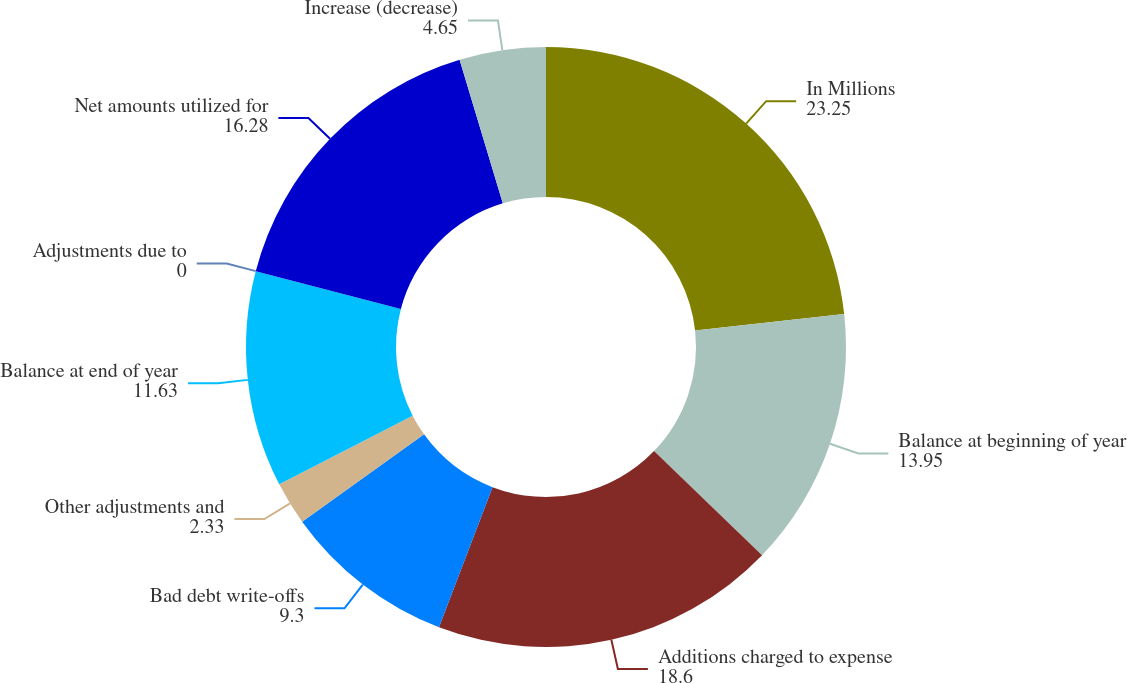<chart> <loc_0><loc_0><loc_500><loc_500><pie_chart><fcel>In Millions<fcel>Balance at beginning of year<fcel>Additions charged to expense<fcel>Bad debt write-offs<fcel>Other adjustments and<fcel>Balance at end of year<fcel>Adjustments due to<fcel>Net amounts utilized for<fcel>Increase (decrease)<nl><fcel>23.25%<fcel>13.95%<fcel>18.6%<fcel>9.3%<fcel>2.33%<fcel>11.63%<fcel>0.0%<fcel>16.28%<fcel>4.65%<nl></chart> 